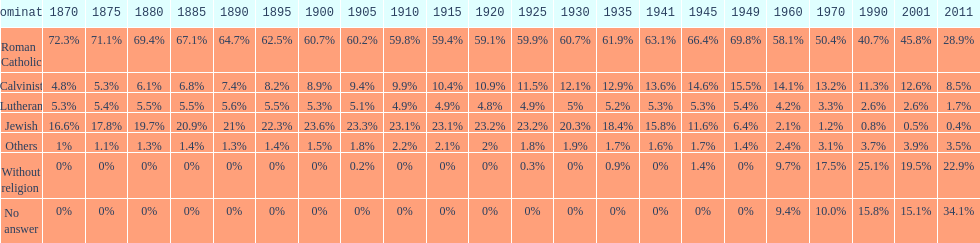In which year was the percentage of those without religion at least 20%? 2011. 